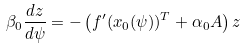<formula> <loc_0><loc_0><loc_500><loc_500>\beta _ { 0 } \frac { d z } { d \psi } = - \left ( f ^ { \prime } ( x _ { 0 } ( \psi ) ) ^ { T } + \alpha _ { 0 } A \right ) z</formula> 